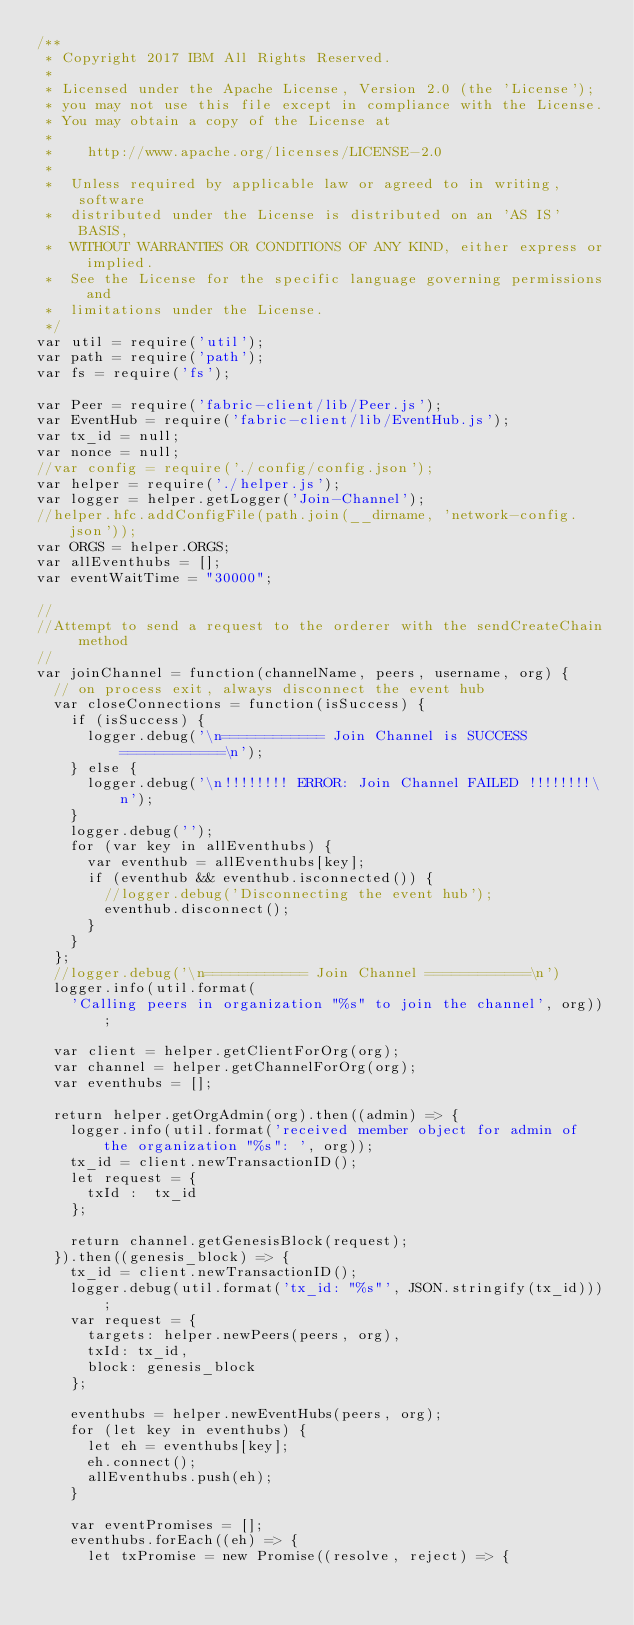<code> <loc_0><loc_0><loc_500><loc_500><_JavaScript_>/**
 * Copyright 2017 IBM All Rights Reserved.
 *
 * Licensed under the Apache License, Version 2.0 (the 'License');
 * you may not use this file except in compliance with the License.
 * You may obtain a copy of the License at
 *
 *    http://www.apache.org/licenses/LICENSE-2.0
 *
 *  Unless required by applicable law or agreed to in writing, software
 *  distributed under the License is distributed on an 'AS IS' BASIS,
 *  WITHOUT WARRANTIES OR CONDITIONS OF ANY KIND, either express or implied.
 *  See the License for the specific language governing permissions and
 *  limitations under the License.
 */
var util = require('util');
var path = require('path');
var fs = require('fs');

var Peer = require('fabric-client/lib/Peer.js');
var EventHub = require('fabric-client/lib/EventHub.js');
var tx_id = null;
var nonce = null;
//var config = require('./config/config.json');
var helper = require('./helper.js');
var logger = helper.getLogger('Join-Channel');
//helper.hfc.addConfigFile(path.join(__dirname, 'network-config.json'));
var ORGS = helper.ORGS;
var allEventhubs = [];
var eventWaitTime = "30000";

//
//Attempt to send a request to the orderer with the sendCreateChain method
//
var joinChannel = function(channelName, peers, username, org) {
	// on process exit, always disconnect the event hub
	var closeConnections = function(isSuccess) {
		if (isSuccess) {
			logger.debug('\n============ Join Channel is SUCCESS ============\n');
		} else {
			logger.debug('\n!!!!!!!! ERROR: Join Channel FAILED !!!!!!!!\n');
		}
		logger.debug('');
		for (var key in allEventhubs) {
			var eventhub = allEventhubs[key];
			if (eventhub && eventhub.isconnected()) {
				//logger.debug('Disconnecting the event hub');
				eventhub.disconnect();
			}
		}
	};
	//logger.debug('\n============ Join Channel ============\n')
	logger.info(util.format(
		'Calling peers in organization "%s" to join the channel', org));

	var client = helper.getClientForOrg(org);
	var channel = helper.getChannelForOrg(org);
	var eventhubs = [];

	return helper.getOrgAdmin(org).then((admin) => {
		logger.info(util.format('received member object for admin of the organization "%s": ', org));
		tx_id = client.newTransactionID();
		let request = {
			txId : 	tx_id
		};

		return channel.getGenesisBlock(request);
	}).then((genesis_block) => {
		tx_id = client.newTransactionID();
		logger.debug(util.format('tx_id: "%s"', JSON.stringify(tx_id)));
		var request = {
			targets: helper.newPeers(peers, org),
			txId: tx_id,
			block: genesis_block
		};

		eventhubs = helper.newEventHubs(peers, org);
		for (let key in eventhubs) {
			let eh = eventhubs[key];
			eh.connect();
			allEventhubs.push(eh);
		}

		var eventPromises = [];
		eventhubs.forEach((eh) => {
			let txPromise = new Promise((resolve, reject) => {</code> 